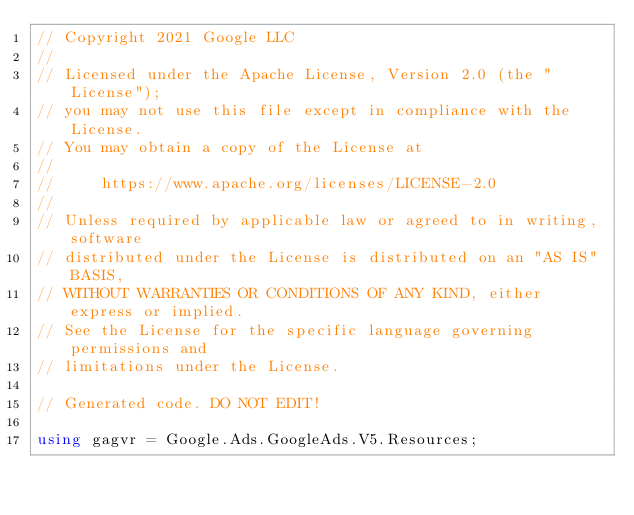Convert code to text. <code><loc_0><loc_0><loc_500><loc_500><_C#_>// Copyright 2021 Google LLC
//
// Licensed under the Apache License, Version 2.0 (the "License");
// you may not use this file except in compliance with the License.
// You may obtain a copy of the License at
//
//     https://www.apache.org/licenses/LICENSE-2.0
//
// Unless required by applicable law or agreed to in writing, software
// distributed under the License is distributed on an "AS IS" BASIS,
// WITHOUT WARRANTIES OR CONDITIONS OF ANY KIND, either express or implied.
// See the License for the specific language governing permissions and
// limitations under the License.

// Generated code. DO NOT EDIT!

using gagvr = Google.Ads.GoogleAds.V5.Resources;
</code> 